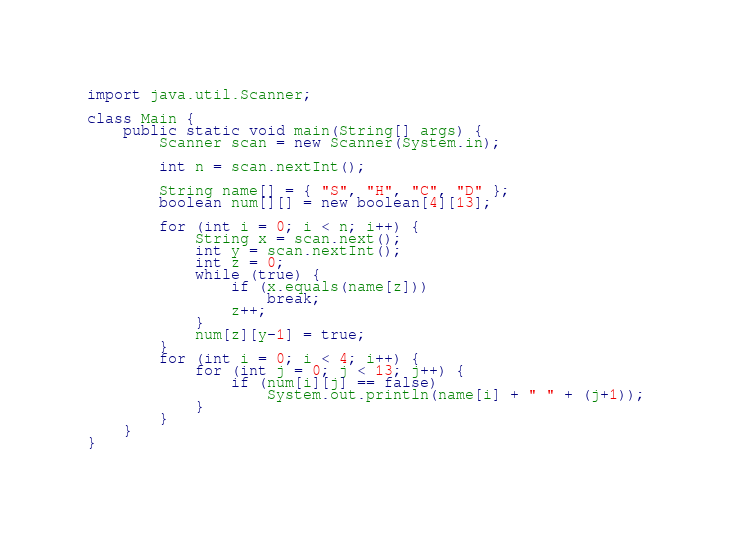<code> <loc_0><loc_0><loc_500><loc_500><_Java_>import java.util.Scanner;

class Main {
	public static void main(String[] args) {
		Scanner scan = new Scanner(System.in);

		int n = scan.nextInt();

		String name[] = { "S", "H", "C", "D" };
		boolean num[][] = new boolean[4][13];

		for (int i = 0; i < n; i++) {
			String x = scan.next();
			int y = scan.nextInt();
			int z = 0;
			while (true) {
				if (x.equals(name[z]))
					break;
				z++;
			}
			num[z][y-1] = true;
		}
		for (int i = 0; i < 4; i++) {
			for (int j = 0; j < 13; j++) {
				if (num[i][j] == false)
					System.out.println(name[i] + " " + (j+1));
			}
		}
	}
}</code> 